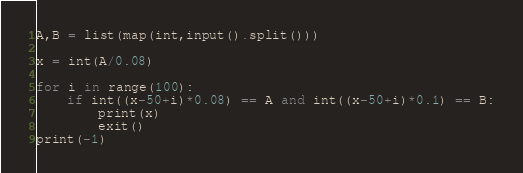<code> <loc_0><loc_0><loc_500><loc_500><_Python_>A,B = list(map(int,input().split()))

x = int(A/0.08)

for i in range(100):
	if int((x-50+i)*0.08) == A and int((x-50+i)*0.1) == B:
		print(x)
		exit()
print(-1)

</code> 